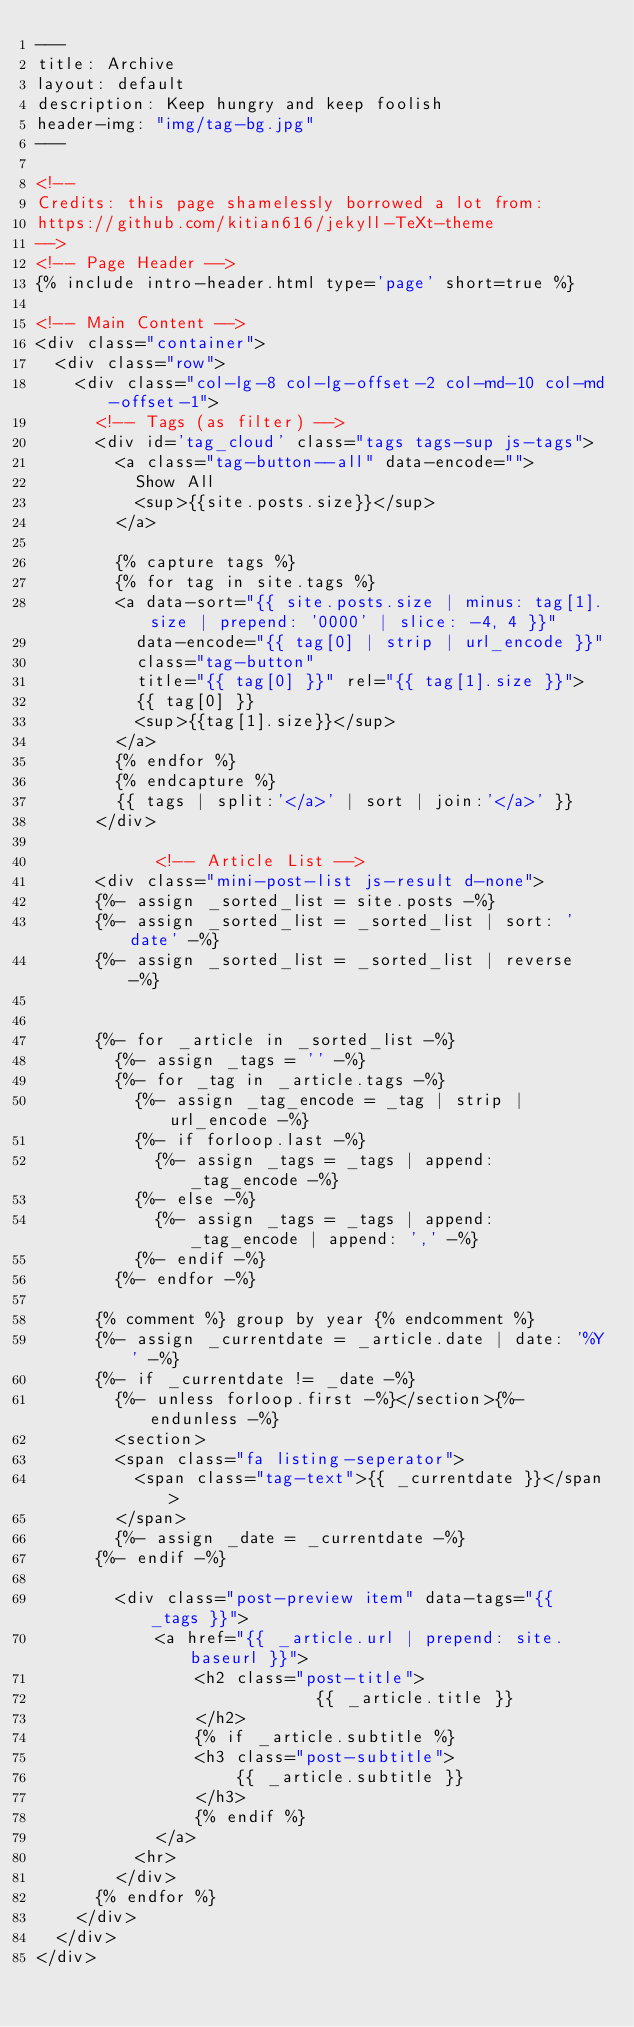Convert code to text. <code><loc_0><loc_0><loc_500><loc_500><_HTML_>---
title: Archive
layout: default
description: Keep hungry and keep foolish
header-img: "img/tag-bg.jpg"
---

<!-- 
Credits: this page shamelessly borrowed a lot from:
https://github.com/kitian616/jekyll-TeXt-theme
-->
<!-- Page Header -->
{% include intro-header.html type='page' short=true %}

<!-- Main Content -->
<div class="container">
	<div class="row">
		<div class="col-lg-8 col-lg-offset-2 col-md-10 col-md-offset-1">
			<!-- Tags (as filter) -->
			<div id='tag_cloud' class="tags tags-sup js-tags">
				<a class="tag-button--all" data-encode="">
					Show All
					<sup>{{site.posts.size}}</sup>
				</a>

				{% capture tags %}
				{% for tag in site.tags %}
				<a data-sort="{{ site.posts.size | minus: tag[1].size | prepend: '0000' | slice: -4, 4 }}"
					data-encode="{{ tag[0] | strip | url_encode }}"
					class="tag-button"
					title="{{ tag[0] }}" rel="{{ tag[1].size }}">
					{{ tag[0] }}
					<sup>{{tag[1].size}}</sup>
				</a>
				{% endfor %}
				{% endcapture %}
        {{ tags | split:'</a>' | sort | join:'</a>' }}
			</div>

            <!-- Article List -->
			<div class="mini-post-list js-result d-none">
			{%- assign _sorted_list = site.posts -%}
			{%- assign _sorted_list = _sorted_list | sort: 'date' -%}
			{%- assign _sorted_list = _sorted_list | reverse -%}


			{%- for _article in _sorted_list -%}
				{%- assign _tags = '' -%}
				{%- for _tag in _article.tags -%}
					{%- assign _tag_encode = _tag | strip | url_encode -%}
					{%- if forloop.last -%}
						{%- assign _tags = _tags | append: _tag_encode -%}
					{%- else -%}
						{%- assign _tags = _tags | append: _tag_encode | append: ',' -%}
					{%- endif -%}
				{%- endfor -%}

			{% comment %} group by year {% endcomment %}
			{%- assign _currentdate = _article.date | date: '%Y' -%}
			{%- if _currentdate != _date -%}
				{%- unless forloop.first -%}</section>{%- endunless -%}
				<section>
				<span class="fa listing-seperator">
					<span class="tag-text">{{ _currentdate }}</span>
				</span>
				{%- assign _date = _currentdate -%}
			{%- endif -%}

				<div class="post-preview item" data-tags="{{ _tags }}">
				    <a href="{{ _article.url | prepend: site.baseurl }}">
				        <h2 class="post-title">
                            {{ _article.title }}
				        </h2>
				        {% if _article.subtitle %}
				        <h3 class="post-subtitle">
				            {{ _article.subtitle }}
				        </h3>
				        {% endif %}
				    </a>
					<hr>
				</div>
			{% endfor %}
		</div>
	</div>
</div>
</code> 